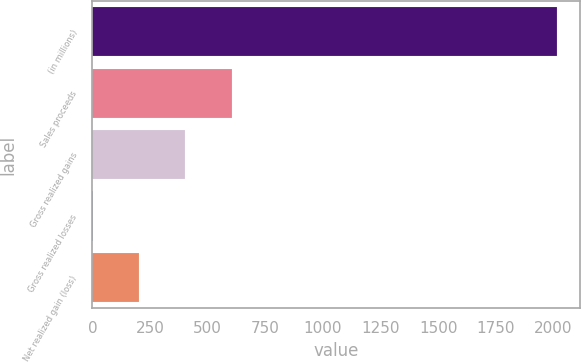Convert chart. <chart><loc_0><loc_0><loc_500><loc_500><bar_chart><fcel>(in millions)<fcel>Sales proceeds<fcel>Gross realized gains<fcel>Gross realized losses<fcel>Net realized gain (loss)<nl><fcel>2013<fcel>604.6<fcel>403.4<fcel>1<fcel>202.2<nl></chart> 